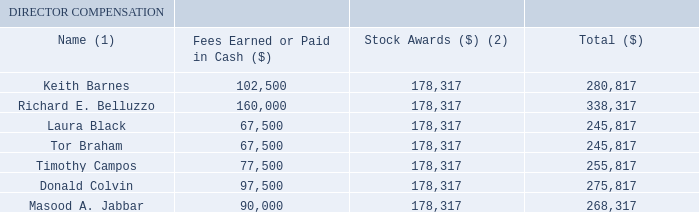The director compensation policies summarized above resulted in the following total compensation for our non-management directors in fiscal year 2019:
Director Compensation Table
(1) Oleg Khaykin, President and Chief Executive Officer, is not included in this table as he was an employee of the Company and as such received no compensation for his services as a director. His compensation is disclosed in the Summary Compensation Table.
(2) The amounts shown in this column represent the grant date fair values of RSUs issued pursuant to the Company’s 2003 Equity Incentive Plan, computed in accordance with Financial Accounting Standards Board Accounting Standards Codification Topic 718 (“FASB ASC Topic 718”), excluding the effect of estimated forfeitures. There can be no assurance that these grant date fair values will ever be realized by the non-employee directors. For information regarding the number of unvested RSUs held by each non-employee director as of the end of fiscal year 2019, see the column “Unvested Restricted Stock Units Outstanding” in the table below
How much did Keith Barnes earn in cash? 102,500. How much did Donald Colvin earn in cash? 97,500. Why was Oleg Khaykin not included in the table? He was an employee of the company and as such received no compensation for his services as a director. What is the difference between  Richard E. Belluzzo's total compensation as compared to Laura Black? (338,317-245,817)
Answer: 92500. What is the summed compensation for the top 3 most compensated directors? (338,317+280,817+275,817)
Answer: 894951. What is the percentage difference of the total compensation between Timothy Campos and Tor Braham?
Answer scale should be: percent. (255,817-245,817)/245,817
Answer: 4.07. 